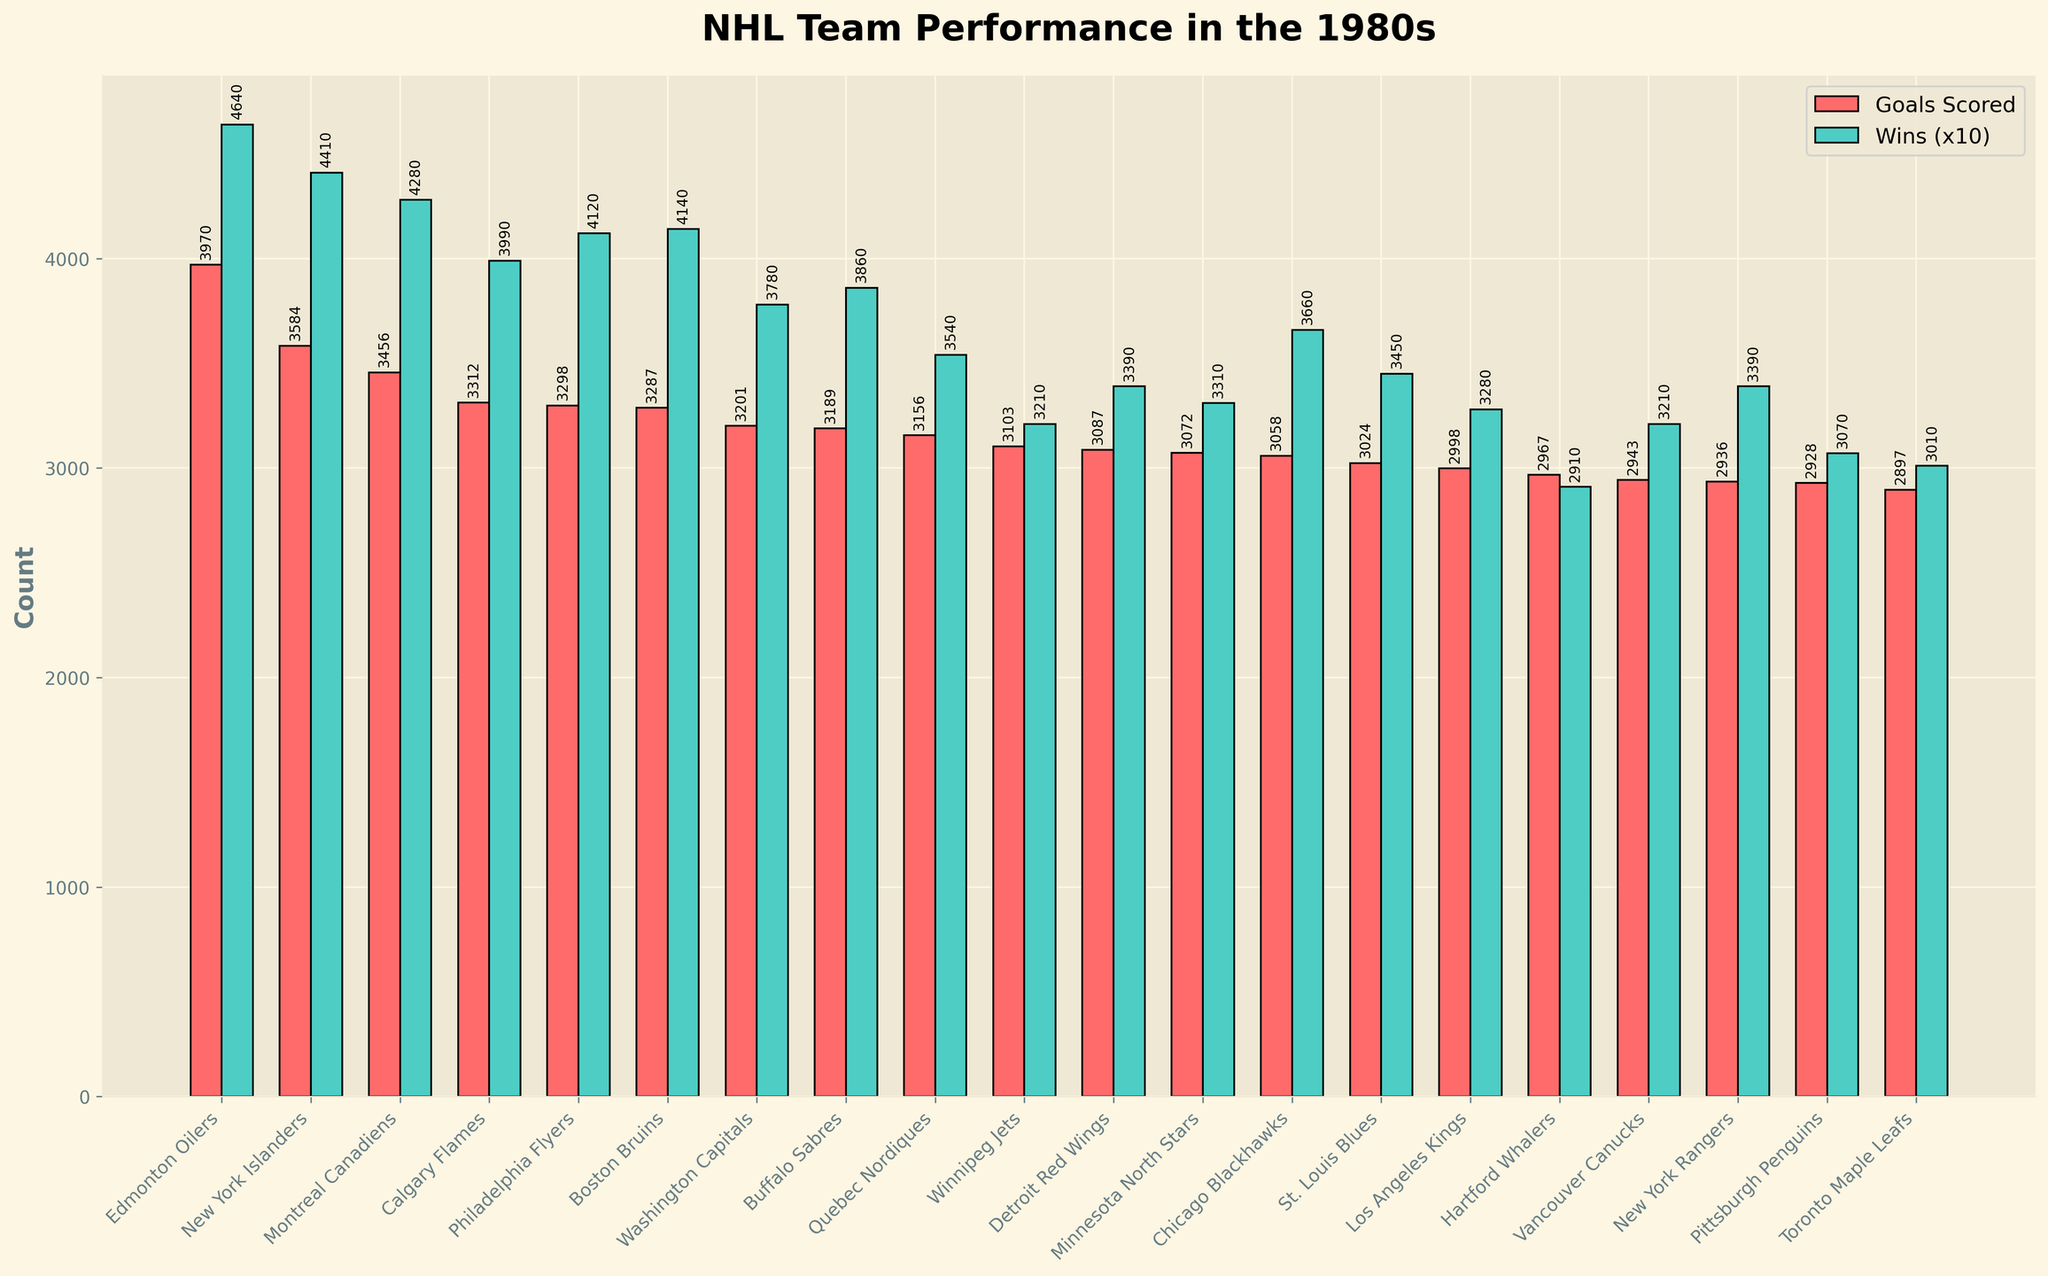Which team scored the most goals? By examining the heights of the red bars representing goals scored, the Edmonton Oilers have the tallest bar. Thus, they scored the most goals.
Answer: Edmonton Oilers Which team had more wins: Boston Bruins or Calgary Flames? By comparing the heights of the green bars representing wins (scaled by 10), the Boston Bruins' bar is higher than Calgary Flames' bar.
Answer: Boston Bruins What is the total number of playoff appearances by the New York Islanders and Montreal Canadiens combined? Referring to the figure, New York Islanders have 10 playoff appearances and Montreal Canadiens also have 10. Adding them together gives 10 + 10 = 20.
Answer: 20 Which team has the shortest red bar and what does it represent? The shortest red bar representing goals scored belongs to the Toronto Maple Leafs.
Answer: Toronto Maple Leafs, goals scored How many fewer wins did the Pittsburgh Penguins have compared to the Winnipeg Jets? By observing the green bars for wins (scaled by 10), Pittsburgh Penguins had 307 wins and Winnipeg Jets had 321 wins. The difference is 321 - 307 = 14.
Answer: 14 Which team has nearly the same number of wins (scaled by 10) as goals scored, and what are those values? The green bar for wins (multiplied by 10) and the red bar for goals are almost equal for St. Louis Blues. They have approximately 345 goals scored and 345 wins.
Answer: St. Louis Blues, 345 goals scored and 345 wins 